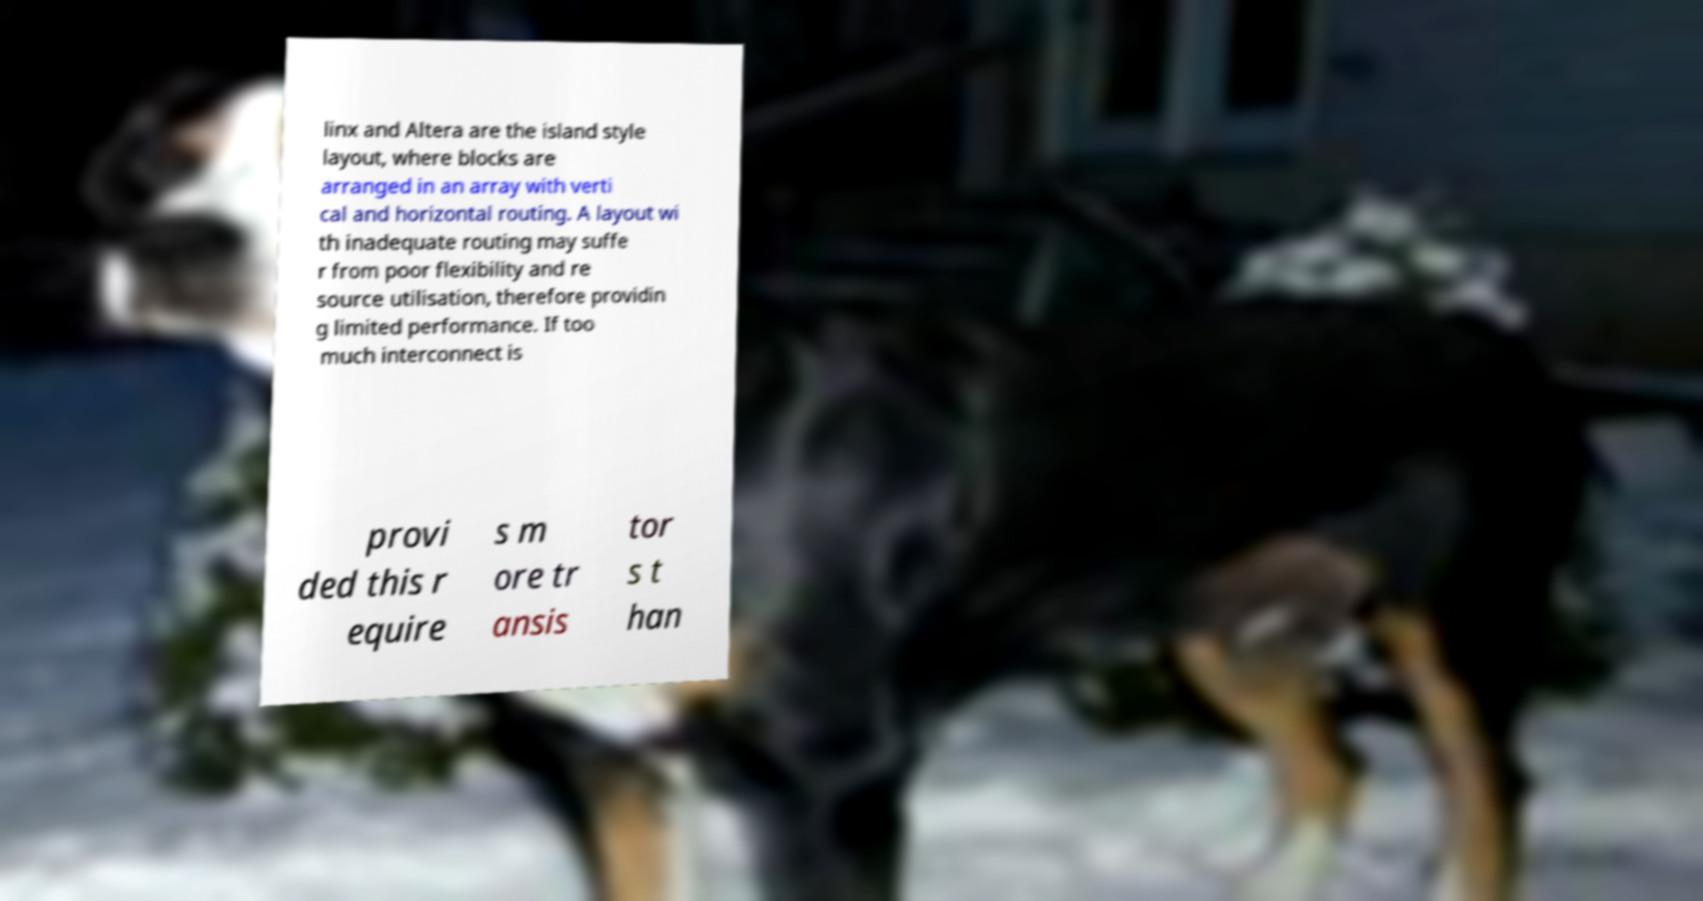Please identify and transcribe the text found in this image. linx and Altera are the island style layout, where blocks are arranged in an array with verti cal and horizontal routing. A layout wi th inadequate routing may suffe r from poor flexibility and re source utilisation, therefore providin g limited performance. If too much interconnect is provi ded this r equire s m ore tr ansis tor s t han 